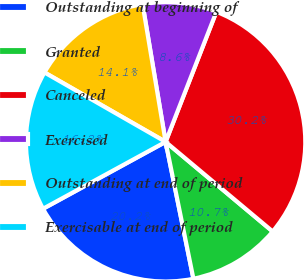Convert chart to OTSL. <chart><loc_0><loc_0><loc_500><loc_500><pie_chart><fcel>Outstanding at beginning of<fcel>Granted<fcel>Canceled<fcel>Exercised<fcel>Outstanding at end of period<fcel>Exercisable at end of period<nl><fcel>20.24%<fcel>10.72%<fcel>30.17%<fcel>8.56%<fcel>14.08%<fcel>16.23%<nl></chart> 